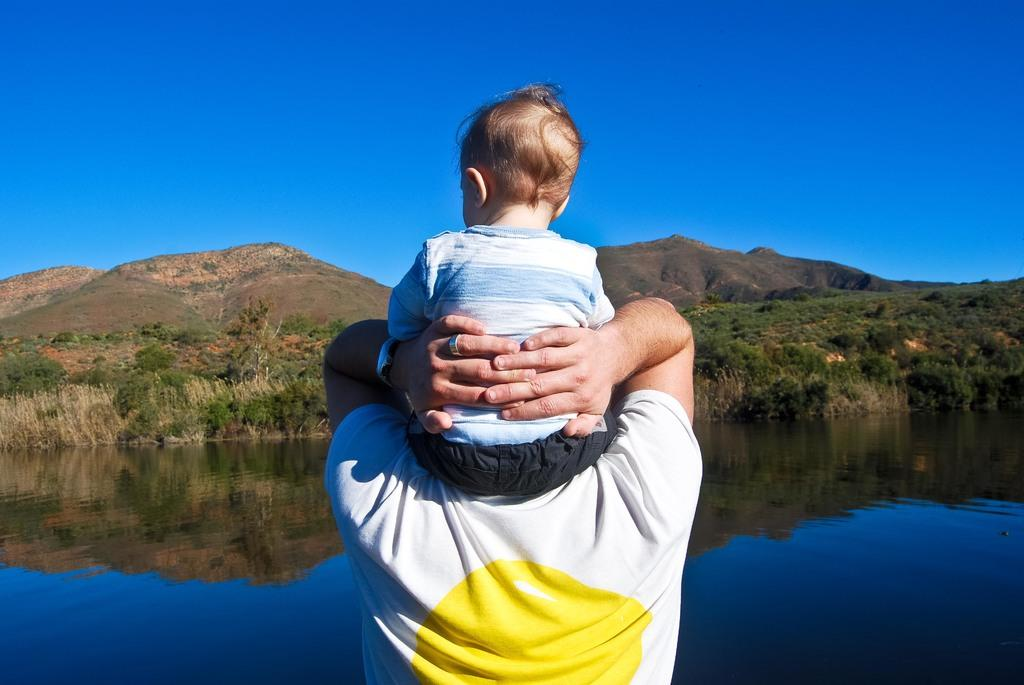What is the main subject of the image? The main subject of the image is a kid. What is the kid doing in the image? The kid is sitting on a man. What can be seen in the background of the image? There is water, hills, trees, plants, and the sky visible in the background of the image. How many pigs are visible in the image? There are no pigs present in the image. What level of difficulty is the kid facing in the image? The image does not indicate any level of difficulty or challenge for the kid. 